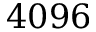<formula> <loc_0><loc_0><loc_500><loc_500>4 0 9 6</formula> 